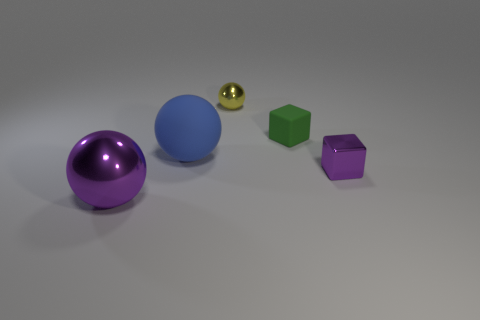What size is the object that is the same color as the metal cube?
Give a very brief answer. Large. Are there an equal number of green cubes in front of the small matte cube and purple metallic spheres that are right of the metallic block?
Give a very brief answer. Yes. What is the color of the tiny block that is in front of the big blue ball?
Offer a terse response. Purple. There is a big metallic ball; is its color the same as the small block on the right side of the tiny green cube?
Ensure brevity in your answer.  Yes. Are there fewer big blue things than tiny gray metallic things?
Keep it short and to the point. No. Do the metal object that is left of the big blue rubber thing and the tiny metallic block have the same color?
Ensure brevity in your answer.  Yes. How many shiny things have the same size as the yellow shiny sphere?
Ensure brevity in your answer.  1. Is there a metal cube that has the same color as the large metallic object?
Make the answer very short. Yes. Does the tiny green thing have the same material as the small yellow ball?
Give a very brief answer. No. How many rubber objects are the same shape as the large metallic thing?
Your answer should be very brief. 1. 